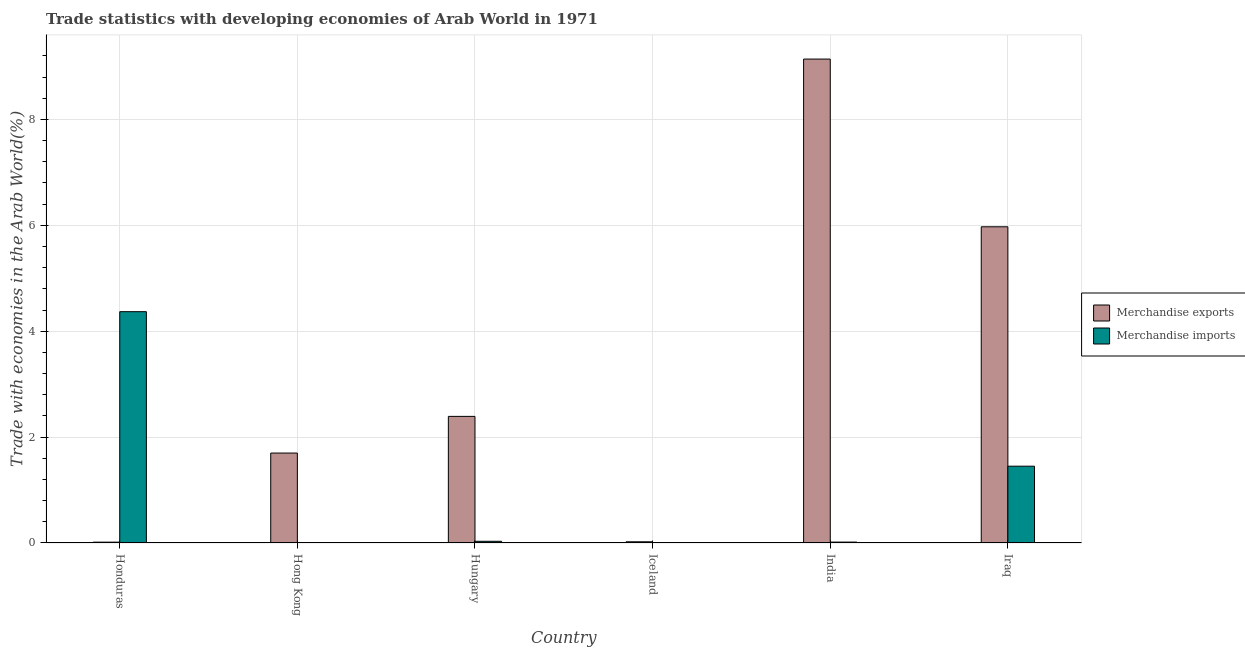How many different coloured bars are there?
Give a very brief answer. 2. Are the number of bars per tick equal to the number of legend labels?
Your answer should be very brief. Yes. How many bars are there on the 2nd tick from the left?
Ensure brevity in your answer.  2. What is the label of the 3rd group of bars from the left?
Provide a succinct answer. Hungary. In how many cases, is the number of bars for a given country not equal to the number of legend labels?
Make the answer very short. 0. What is the merchandise exports in Hong Kong?
Ensure brevity in your answer.  1.7. Across all countries, what is the maximum merchandise imports?
Give a very brief answer. 4.37. Across all countries, what is the minimum merchandise exports?
Offer a terse response. 0.02. In which country was the merchandise imports minimum?
Make the answer very short. Hong Kong. What is the total merchandise exports in the graph?
Your answer should be compact. 19.24. What is the difference between the merchandise exports in Iceland and that in Iraq?
Provide a short and direct response. -5.95. What is the difference between the merchandise exports in Honduras and the merchandise imports in Iraq?
Your response must be concise. -1.43. What is the average merchandise exports per country?
Your answer should be compact. 3.21. What is the difference between the merchandise imports and merchandise exports in Hungary?
Your answer should be compact. -2.36. What is the ratio of the merchandise exports in Honduras to that in India?
Provide a short and direct response. 0. Is the difference between the merchandise exports in Hungary and India greater than the difference between the merchandise imports in Hungary and India?
Your response must be concise. No. What is the difference between the highest and the second highest merchandise exports?
Ensure brevity in your answer.  3.17. What is the difference between the highest and the lowest merchandise imports?
Keep it short and to the point. 4.37. In how many countries, is the merchandise exports greater than the average merchandise exports taken over all countries?
Make the answer very short. 2. What does the 2nd bar from the left in Honduras represents?
Your answer should be very brief. Merchandise imports. What does the 1st bar from the right in Iceland represents?
Your answer should be compact. Merchandise imports. Are all the bars in the graph horizontal?
Keep it short and to the point. No. What is the difference between two consecutive major ticks on the Y-axis?
Your answer should be very brief. 2. Are the values on the major ticks of Y-axis written in scientific E-notation?
Offer a terse response. No. Does the graph contain grids?
Provide a succinct answer. Yes. What is the title of the graph?
Keep it short and to the point. Trade statistics with developing economies of Arab World in 1971. Does "Food" appear as one of the legend labels in the graph?
Provide a short and direct response. No. What is the label or title of the Y-axis?
Offer a very short reply. Trade with economies in the Arab World(%). What is the Trade with economies in the Arab World(%) of Merchandise exports in Honduras?
Offer a terse response. 0.02. What is the Trade with economies in the Arab World(%) in Merchandise imports in Honduras?
Your answer should be very brief. 4.37. What is the Trade with economies in the Arab World(%) in Merchandise exports in Hong Kong?
Give a very brief answer. 1.7. What is the Trade with economies in the Arab World(%) in Merchandise imports in Hong Kong?
Give a very brief answer. 0. What is the Trade with economies in the Arab World(%) in Merchandise exports in Hungary?
Offer a very short reply. 2.39. What is the Trade with economies in the Arab World(%) in Merchandise imports in Hungary?
Give a very brief answer. 0.03. What is the Trade with economies in the Arab World(%) in Merchandise exports in Iceland?
Offer a very short reply. 0.02. What is the Trade with economies in the Arab World(%) of Merchandise imports in Iceland?
Make the answer very short. 0. What is the Trade with economies in the Arab World(%) of Merchandise exports in India?
Your response must be concise. 9.14. What is the Trade with economies in the Arab World(%) of Merchandise imports in India?
Offer a terse response. 0.02. What is the Trade with economies in the Arab World(%) in Merchandise exports in Iraq?
Provide a short and direct response. 5.97. What is the Trade with economies in the Arab World(%) of Merchandise imports in Iraq?
Keep it short and to the point. 1.45. Across all countries, what is the maximum Trade with economies in the Arab World(%) in Merchandise exports?
Your answer should be very brief. 9.14. Across all countries, what is the maximum Trade with economies in the Arab World(%) of Merchandise imports?
Make the answer very short. 4.37. Across all countries, what is the minimum Trade with economies in the Arab World(%) in Merchandise exports?
Ensure brevity in your answer.  0.02. Across all countries, what is the minimum Trade with economies in the Arab World(%) in Merchandise imports?
Give a very brief answer. 0. What is the total Trade with economies in the Arab World(%) of Merchandise exports in the graph?
Provide a succinct answer. 19.24. What is the total Trade with economies in the Arab World(%) of Merchandise imports in the graph?
Ensure brevity in your answer.  5.87. What is the difference between the Trade with economies in the Arab World(%) in Merchandise exports in Honduras and that in Hong Kong?
Ensure brevity in your answer.  -1.68. What is the difference between the Trade with economies in the Arab World(%) in Merchandise imports in Honduras and that in Hong Kong?
Your answer should be compact. 4.37. What is the difference between the Trade with economies in the Arab World(%) in Merchandise exports in Honduras and that in Hungary?
Provide a succinct answer. -2.38. What is the difference between the Trade with economies in the Arab World(%) in Merchandise imports in Honduras and that in Hungary?
Your answer should be very brief. 4.34. What is the difference between the Trade with economies in the Arab World(%) of Merchandise exports in Honduras and that in Iceland?
Make the answer very short. -0.01. What is the difference between the Trade with economies in the Arab World(%) in Merchandise imports in Honduras and that in Iceland?
Your response must be concise. 4.37. What is the difference between the Trade with economies in the Arab World(%) in Merchandise exports in Honduras and that in India?
Provide a succinct answer. -9.12. What is the difference between the Trade with economies in the Arab World(%) of Merchandise imports in Honduras and that in India?
Your answer should be compact. 4.35. What is the difference between the Trade with economies in the Arab World(%) of Merchandise exports in Honduras and that in Iraq?
Ensure brevity in your answer.  -5.96. What is the difference between the Trade with economies in the Arab World(%) of Merchandise imports in Honduras and that in Iraq?
Your response must be concise. 2.92. What is the difference between the Trade with economies in the Arab World(%) of Merchandise exports in Hong Kong and that in Hungary?
Offer a very short reply. -0.69. What is the difference between the Trade with economies in the Arab World(%) of Merchandise imports in Hong Kong and that in Hungary?
Provide a succinct answer. -0.03. What is the difference between the Trade with economies in the Arab World(%) in Merchandise exports in Hong Kong and that in Iceland?
Make the answer very short. 1.68. What is the difference between the Trade with economies in the Arab World(%) of Merchandise imports in Hong Kong and that in Iceland?
Offer a very short reply. -0. What is the difference between the Trade with economies in the Arab World(%) in Merchandise exports in Hong Kong and that in India?
Ensure brevity in your answer.  -7.44. What is the difference between the Trade with economies in the Arab World(%) of Merchandise imports in Hong Kong and that in India?
Offer a very short reply. -0.01. What is the difference between the Trade with economies in the Arab World(%) of Merchandise exports in Hong Kong and that in Iraq?
Ensure brevity in your answer.  -4.27. What is the difference between the Trade with economies in the Arab World(%) of Merchandise imports in Hong Kong and that in Iraq?
Give a very brief answer. -1.45. What is the difference between the Trade with economies in the Arab World(%) of Merchandise exports in Hungary and that in Iceland?
Offer a very short reply. 2.37. What is the difference between the Trade with economies in the Arab World(%) in Merchandise imports in Hungary and that in Iceland?
Offer a terse response. 0.03. What is the difference between the Trade with economies in the Arab World(%) of Merchandise exports in Hungary and that in India?
Make the answer very short. -6.75. What is the difference between the Trade with economies in the Arab World(%) in Merchandise imports in Hungary and that in India?
Your answer should be compact. 0.01. What is the difference between the Trade with economies in the Arab World(%) of Merchandise exports in Hungary and that in Iraq?
Keep it short and to the point. -3.58. What is the difference between the Trade with economies in the Arab World(%) in Merchandise imports in Hungary and that in Iraq?
Ensure brevity in your answer.  -1.42. What is the difference between the Trade with economies in the Arab World(%) in Merchandise exports in Iceland and that in India?
Provide a short and direct response. -9.12. What is the difference between the Trade with economies in the Arab World(%) in Merchandise imports in Iceland and that in India?
Offer a terse response. -0.01. What is the difference between the Trade with economies in the Arab World(%) of Merchandise exports in Iceland and that in Iraq?
Offer a very short reply. -5.95. What is the difference between the Trade with economies in the Arab World(%) of Merchandise imports in Iceland and that in Iraq?
Your answer should be compact. -1.45. What is the difference between the Trade with economies in the Arab World(%) in Merchandise exports in India and that in Iraq?
Provide a succinct answer. 3.17. What is the difference between the Trade with economies in the Arab World(%) in Merchandise imports in India and that in Iraq?
Provide a succinct answer. -1.43. What is the difference between the Trade with economies in the Arab World(%) of Merchandise exports in Honduras and the Trade with economies in the Arab World(%) of Merchandise imports in Hong Kong?
Your response must be concise. 0.01. What is the difference between the Trade with economies in the Arab World(%) of Merchandise exports in Honduras and the Trade with economies in the Arab World(%) of Merchandise imports in Hungary?
Make the answer very short. -0.02. What is the difference between the Trade with economies in the Arab World(%) of Merchandise exports in Honduras and the Trade with economies in the Arab World(%) of Merchandise imports in Iceland?
Your answer should be very brief. 0.01. What is the difference between the Trade with economies in the Arab World(%) of Merchandise exports in Honduras and the Trade with economies in the Arab World(%) of Merchandise imports in India?
Your response must be concise. -0. What is the difference between the Trade with economies in the Arab World(%) of Merchandise exports in Honduras and the Trade with economies in the Arab World(%) of Merchandise imports in Iraq?
Provide a short and direct response. -1.43. What is the difference between the Trade with economies in the Arab World(%) of Merchandise exports in Hong Kong and the Trade with economies in the Arab World(%) of Merchandise imports in Hungary?
Your answer should be very brief. 1.67. What is the difference between the Trade with economies in the Arab World(%) of Merchandise exports in Hong Kong and the Trade with economies in the Arab World(%) of Merchandise imports in Iceland?
Offer a very short reply. 1.7. What is the difference between the Trade with economies in the Arab World(%) in Merchandise exports in Hong Kong and the Trade with economies in the Arab World(%) in Merchandise imports in India?
Your answer should be very brief. 1.68. What is the difference between the Trade with economies in the Arab World(%) in Merchandise exports in Hong Kong and the Trade with economies in the Arab World(%) in Merchandise imports in Iraq?
Keep it short and to the point. 0.25. What is the difference between the Trade with economies in the Arab World(%) of Merchandise exports in Hungary and the Trade with economies in the Arab World(%) of Merchandise imports in Iceland?
Make the answer very short. 2.39. What is the difference between the Trade with economies in the Arab World(%) of Merchandise exports in Hungary and the Trade with economies in the Arab World(%) of Merchandise imports in India?
Keep it short and to the point. 2.37. What is the difference between the Trade with economies in the Arab World(%) of Merchandise exports in Hungary and the Trade with economies in the Arab World(%) of Merchandise imports in Iraq?
Give a very brief answer. 0.94. What is the difference between the Trade with economies in the Arab World(%) of Merchandise exports in Iceland and the Trade with economies in the Arab World(%) of Merchandise imports in India?
Your response must be concise. 0.01. What is the difference between the Trade with economies in the Arab World(%) in Merchandise exports in Iceland and the Trade with economies in the Arab World(%) in Merchandise imports in Iraq?
Offer a terse response. -1.43. What is the difference between the Trade with economies in the Arab World(%) of Merchandise exports in India and the Trade with economies in the Arab World(%) of Merchandise imports in Iraq?
Provide a short and direct response. 7.69. What is the average Trade with economies in the Arab World(%) of Merchandise exports per country?
Offer a very short reply. 3.21. What is the average Trade with economies in the Arab World(%) of Merchandise imports per country?
Ensure brevity in your answer.  0.98. What is the difference between the Trade with economies in the Arab World(%) of Merchandise exports and Trade with economies in the Arab World(%) of Merchandise imports in Honduras?
Make the answer very short. -4.35. What is the difference between the Trade with economies in the Arab World(%) in Merchandise exports and Trade with economies in the Arab World(%) in Merchandise imports in Hong Kong?
Offer a very short reply. 1.7. What is the difference between the Trade with economies in the Arab World(%) of Merchandise exports and Trade with economies in the Arab World(%) of Merchandise imports in Hungary?
Your answer should be compact. 2.36. What is the difference between the Trade with economies in the Arab World(%) in Merchandise exports and Trade with economies in the Arab World(%) in Merchandise imports in Iceland?
Give a very brief answer. 0.02. What is the difference between the Trade with economies in the Arab World(%) of Merchandise exports and Trade with economies in the Arab World(%) of Merchandise imports in India?
Offer a very short reply. 9.12. What is the difference between the Trade with economies in the Arab World(%) of Merchandise exports and Trade with economies in the Arab World(%) of Merchandise imports in Iraq?
Keep it short and to the point. 4.52. What is the ratio of the Trade with economies in the Arab World(%) of Merchandise exports in Honduras to that in Hong Kong?
Offer a very short reply. 0.01. What is the ratio of the Trade with economies in the Arab World(%) of Merchandise imports in Honduras to that in Hong Kong?
Your answer should be very brief. 1468.67. What is the ratio of the Trade with economies in the Arab World(%) of Merchandise exports in Honduras to that in Hungary?
Your answer should be very brief. 0.01. What is the ratio of the Trade with economies in the Arab World(%) in Merchandise imports in Honduras to that in Hungary?
Keep it short and to the point. 136.18. What is the ratio of the Trade with economies in the Arab World(%) of Merchandise exports in Honduras to that in Iceland?
Make the answer very short. 0.7. What is the ratio of the Trade with economies in the Arab World(%) of Merchandise imports in Honduras to that in Iceland?
Keep it short and to the point. 1285.76. What is the ratio of the Trade with economies in the Arab World(%) in Merchandise exports in Honduras to that in India?
Give a very brief answer. 0. What is the ratio of the Trade with economies in the Arab World(%) of Merchandise imports in Honduras to that in India?
Offer a very short reply. 256.02. What is the ratio of the Trade with economies in the Arab World(%) in Merchandise exports in Honduras to that in Iraq?
Provide a succinct answer. 0. What is the ratio of the Trade with economies in the Arab World(%) of Merchandise imports in Honduras to that in Iraq?
Offer a very short reply. 3.01. What is the ratio of the Trade with economies in the Arab World(%) of Merchandise exports in Hong Kong to that in Hungary?
Offer a terse response. 0.71. What is the ratio of the Trade with economies in the Arab World(%) of Merchandise imports in Hong Kong to that in Hungary?
Provide a succinct answer. 0.09. What is the ratio of the Trade with economies in the Arab World(%) of Merchandise exports in Hong Kong to that in Iceland?
Your response must be concise. 74.81. What is the ratio of the Trade with economies in the Arab World(%) of Merchandise imports in Hong Kong to that in Iceland?
Offer a very short reply. 0.88. What is the ratio of the Trade with economies in the Arab World(%) in Merchandise exports in Hong Kong to that in India?
Your answer should be compact. 0.19. What is the ratio of the Trade with economies in the Arab World(%) of Merchandise imports in Hong Kong to that in India?
Offer a terse response. 0.17. What is the ratio of the Trade with economies in the Arab World(%) of Merchandise exports in Hong Kong to that in Iraq?
Keep it short and to the point. 0.28. What is the ratio of the Trade with economies in the Arab World(%) in Merchandise imports in Hong Kong to that in Iraq?
Ensure brevity in your answer.  0. What is the ratio of the Trade with economies in the Arab World(%) of Merchandise exports in Hungary to that in Iceland?
Your response must be concise. 105.31. What is the ratio of the Trade with economies in the Arab World(%) of Merchandise imports in Hungary to that in Iceland?
Your response must be concise. 9.44. What is the ratio of the Trade with economies in the Arab World(%) in Merchandise exports in Hungary to that in India?
Your answer should be very brief. 0.26. What is the ratio of the Trade with economies in the Arab World(%) in Merchandise imports in Hungary to that in India?
Offer a terse response. 1.88. What is the ratio of the Trade with economies in the Arab World(%) in Merchandise exports in Hungary to that in Iraq?
Make the answer very short. 0.4. What is the ratio of the Trade with economies in the Arab World(%) in Merchandise imports in Hungary to that in Iraq?
Make the answer very short. 0.02. What is the ratio of the Trade with economies in the Arab World(%) in Merchandise exports in Iceland to that in India?
Ensure brevity in your answer.  0. What is the ratio of the Trade with economies in the Arab World(%) of Merchandise imports in Iceland to that in India?
Your answer should be very brief. 0.2. What is the ratio of the Trade with economies in the Arab World(%) in Merchandise exports in Iceland to that in Iraq?
Keep it short and to the point. 0. What is the ratio of the Trade with economies in the Arab World(%) of Merchandise imports in Iceland to that in Iraq?
Your response must be concise. 0. What is the ratio of the Trade with economies in the Arab World(%) of Merchandise exports in India to that in Iraq?
Keep it short and to the point. 1.53. What is the ratio of the Trade with economies in the Arab World(%) of Merchandise imports in India to that in Iraq?
Your response must be concise. 0.01. What is the difference between the highest and the second highest Trade with economies in the Arab World(%) in Merchandise exports?
Your answer should be compact. 3.17. What is the difference between the highest and the second highest Trade with economies in the Arab World(%) of Merchandise imports?
Provide a succinct answer. 2.92. What is the difference between the highest and the lowest Trade with economies in the Arab World(%) in Merchandise exports?
Ensure brevity in your answer.  9.12. What is the difference between the highest and the lowest Trade with economies in the Arab World(%) in Merchandise imports?
Make the answer very short. 4.37. 